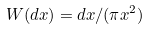<formula> <loc_0><loc_0><loc_500><loc_500>W ( d x ) = d x / ( \pi x ^ { 2 } )</formula> 